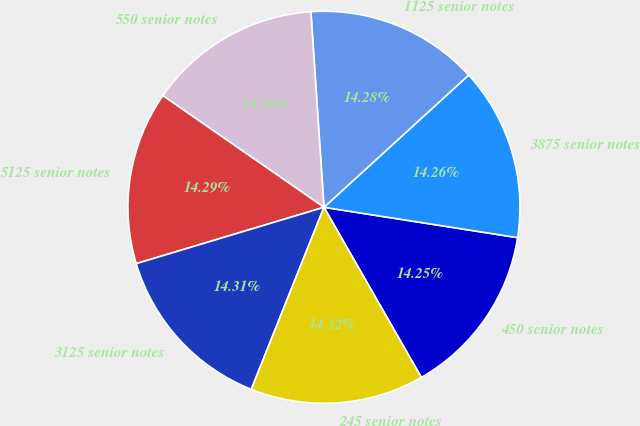Convert chart. <chart><loc_0><loc_0><loc_500><loc_500><pie_chart><fcel>450 senior notes<fcel>3875 senior notes<fcel>1125 senior notes<fcel>550 senior notes<fcel>5125 senior notes<fcel>3125 senior notes<fcel>245 senior notes<nl><fcel>14.25%<fcel>14.26%<fcel>14.28%<fcel>14.29%<fcel>14.29%<fcel>14.31%<fcel>14.32%<nl></chart> 